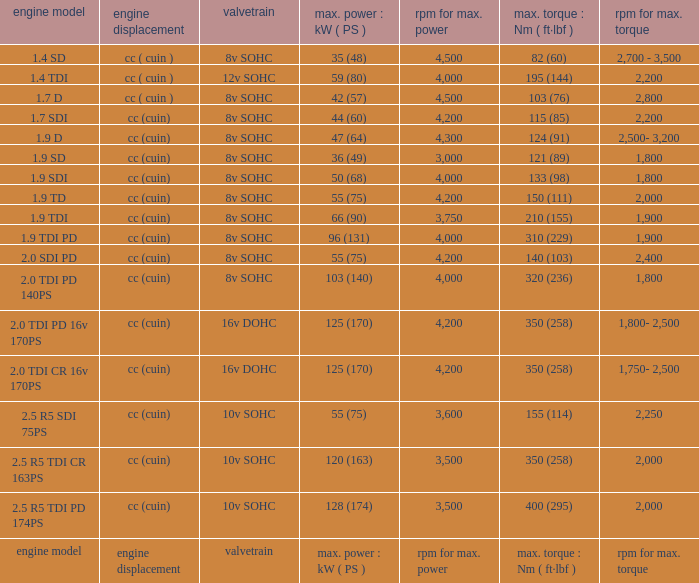In an engine model that is also an engine model, what kind of valvetrain can be found? Valvetrain. 